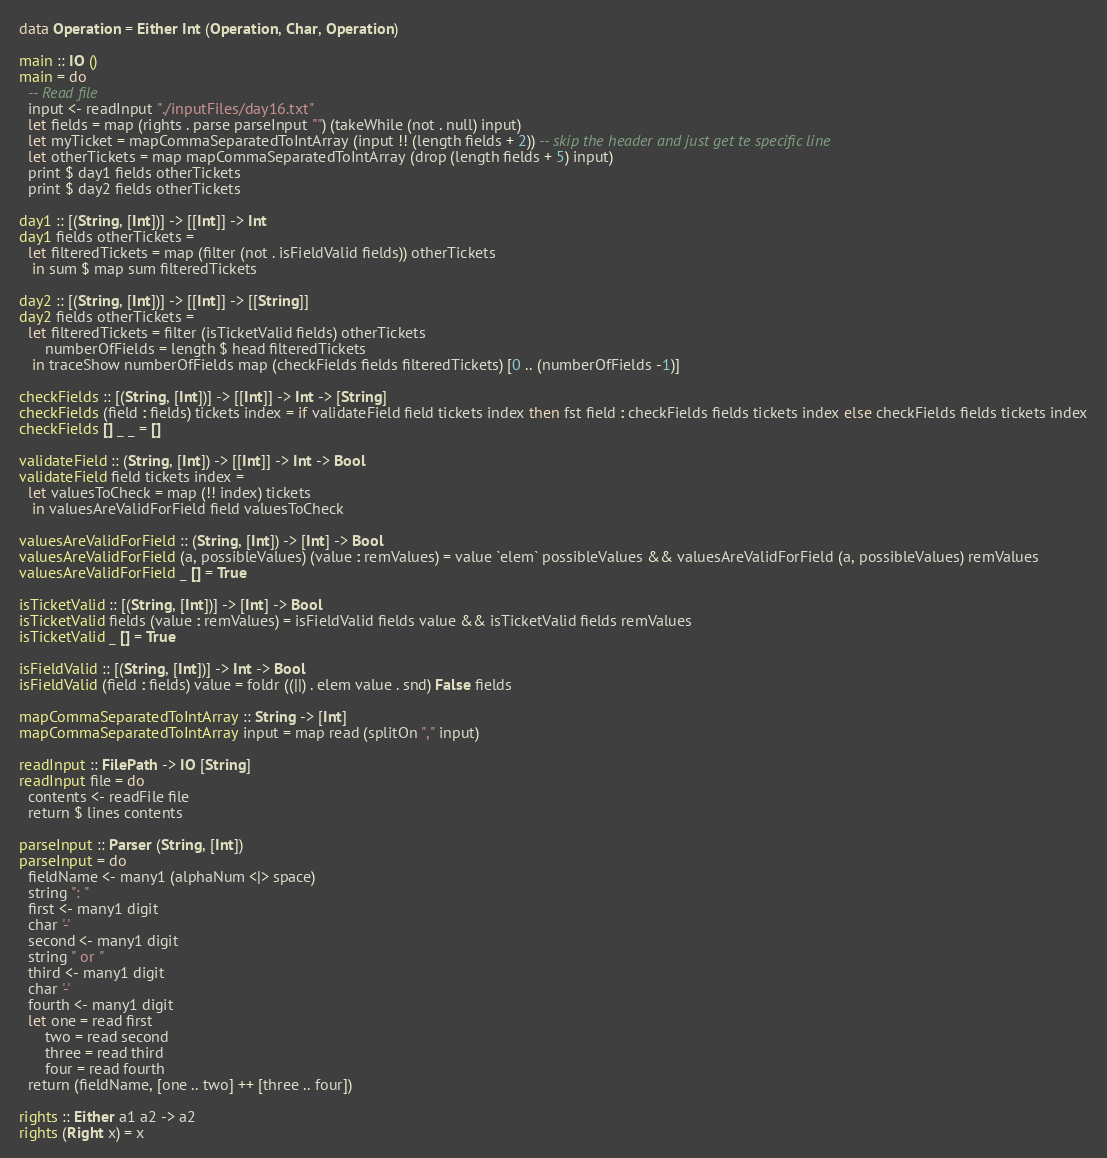Convert code to text. <code><loc_0><loc_0><loc_500><loc_500><_Haskell_>

data Operation = Either Int (Operation, Char, Operation)

main :: IO ()
main = do
  -- Read file
  input <- readInput "./inputFiles/day16.txt"
  let fields = map (rights . parse parseInput "") (takeWhile (not . null) input)
  let myTicket = mapCommaSeparatedToIntArray (input !! (length fields + 2)) -- skip the header and just get te specific line
  let otherTickets = map mapCommaSeparatedToIntArray (drop (length fields + 5) input)
  print $ day1 fields otherTickets
  print $ day2 fields otherTickets

day1 :: [(String, [Int])] -> [[Int]] -> Int
day1 fields otherTickets =
  let filteredTickets = map (filter (not . isFieldValid fields)) otherTickets
   in sum $ map sum filteredTickets

day2 :: [(String, [Int])] -> [[Int]] -> [[String]]
day2 fields otherTickets =
  let filteredTickets = filter (isTicketValid fields) otherTickets
      numberOfFields = length $ head filteredTickets
   in traceShow numberOfFields map (checkFields fields filteredTickets) [0 .. (numberOfFields -1)]

checkFields :: [(String, [Int])] -> [[Int]] -> Int -> [String]
checkFields (field : fields) tickets index = if validateField field tickets index then fst field : checkFields fields tickets index else checkFields fields tickets index
checkFields [] _ _ = []

validateField :: (String, [Int]) -> [[Int]] -> Int -> Bool
validateField field tickets index =
  let valuesToCheck = map (!! index) tickets
   in valuesAreValidForField field valuesToCheck

valuesAreValidForField :: (String, [Int]) -> [Int] -> Bool
valuesAreValidForField (a, possibleValues) (value : remValues) = value `elem` possibleValues && valuesAreValidForField (a, possibleValues) remValues
valuesAreValidForField _ [] = True

isTicketValid :: [(String, [Int])] -> [Int] -> Bool
isTicketValid fields (value : remValues) = isFieldValid fields value && isTicketValid fields remValues
isTicketValid _ [] = True

isFieldValid :: [(String, [Int])] -> Int -> Bool
isFieldValid (field : fields) value = foldr ((||) . elem value . snd) False fields

mapCommaSeparatedToIntArray :: String -> [Int]
mapCommaSeparatedToIntArray input = map read (splitOn "," input)

readInput :: FilePath -> IO [String]
readInput file = do
  contents <- readFile file
  return $ lines contents

parseInput :: Parser (String, [Int])
parseInput = do
  fieldName <- many1 (alphaNum <|> space)
  string ": "
  first <- many1 digit
  char '-'
  second <- many1 digit
  string " or "
  third <- many1 digit
  char '-'
  fourth <- many1 digit
  let one = read first
      two = read second
      three = read third
      four = read fourth
  return (fieldName, [one .. two] ++ [three .. four])

rights :: Either a1 a2 -> a2
rights (Right x) = x</code> 